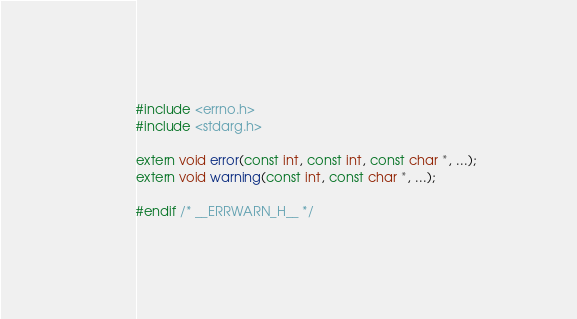Convert code to text. <code><loc_0><loc_0><loc_500><loc_500><_C_>#include <errno.h>
#include <stdarg.h>

extern void error(const int, const int, const char *, ...);
extern void warning(const int, const char *, ...);

#endif /* __ERRWARN_H__ */

</code> 